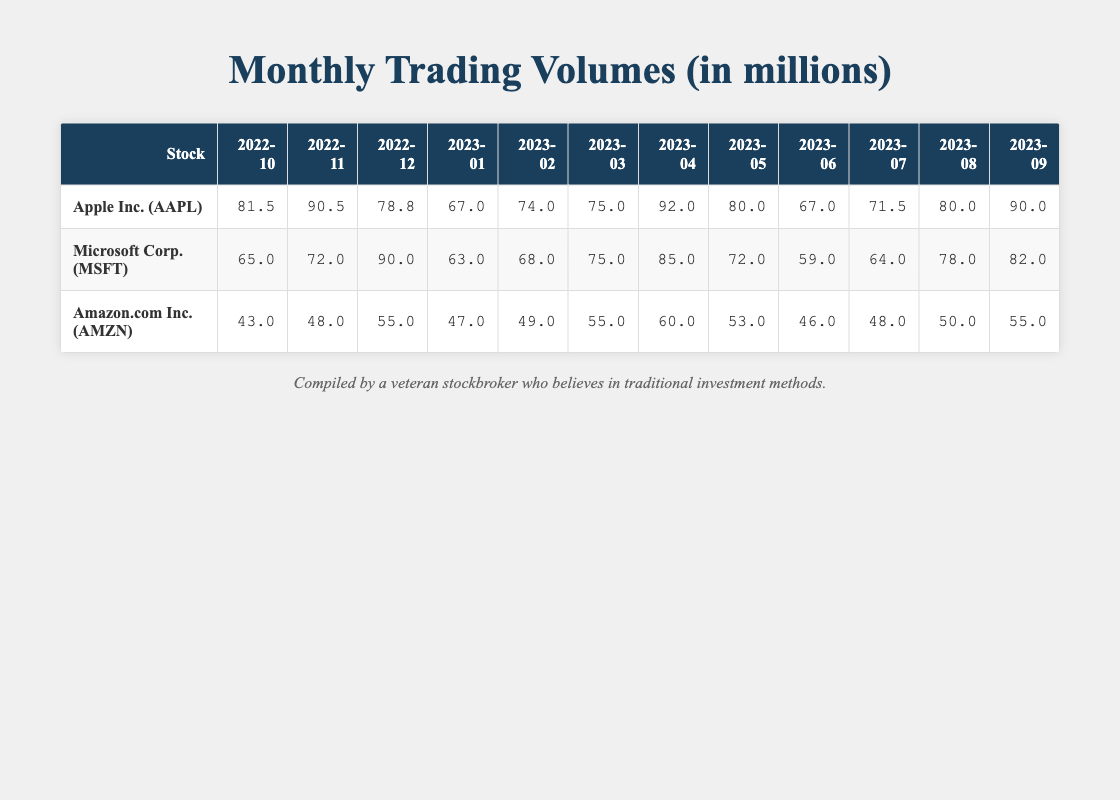What was the trading volume of Apple Inc. in November 2022? By locating the row for Apple Inc. in the month of November 2022 in the table, we can see that the trading volume listed is 90.5 million.
Answer: 90.5 million Which company had the highest trading volume in April 2023? In April 2023, when comparing the trading volumes for Apple Inc. (92.0), Microsoft Corp. (85.0), and Amazon.com Inc. (60.0), it is clear that Apple Inc. had the highest trading volume at 92.0 million.
Answer: Apple Inc What is the total trading volume of Microsoft Corp. over the past year? Summing the trading volumes for Microsoft Corp. across the year yields: 65.0 + 72.0 + 90.0 + 63.0 + 68.0 + 75.0 + 85.0 + 72.0 + 59.0 + 64.0 + 78.0 + 82.0 =  86.5 million.
Answer: 853.0 million Was there a month where Amazon.com Inc. had a trading volume higher than 60 million? By checking the trading volumes for Amazon.com Inc., the months with values are: 43.0, 48.0, 55.0, 47.0, 49.0, 55.0, 60.0, 53.0, 46.0, 48.0, 50.0, 55.0. Only in April 2023 did Amazon.com Inc. reach exactly 60.0 million, so yes, there was.
Answer: Yes What is the average trading volume for Apple Inc. in the first half of 2023? The trading volumes for Apple Inc. in the first half of 2023 are: 67.0, 74.0, 75.0, 92.0, 80.0, 67.0. To calculate the average, we sum these values: 67.0 + 74.0 + 75.0 + 92.0 + 80.0 + 67.0 = 455.0, and since there are 6 months, we divide by 6 which gives us an average of 75.83 million.
Answer: 75.83 million In which month did Microsoft Corp. have the lowest trading volume? Locating Microsoft Corp.'s trading volumes, the lowest value is 59.0 which occurred in June 2023, making it the month with the lowest trading volume.
Answer: June 2023 What was the difference in trading volume for Amazon.com Inc. between October 2022 and December 2022? The trading volume for Amazon.com Inc. in October 2022 is 43.0 million and in December 2022 is 55.0 million. The difference can be calculated as 55.0 - 43.0 = 12.0 million.
Answer: 12.0 million Which company consistently showed an upward trend in trading volume across the months from October 2022 to September 2023? Upon reviewing the data, Apple Inc. shows a consistent upward trend in trading volume from 81.5 million in October 2022 to 90.0 million in September 2023.
Answer: Apple Inc 